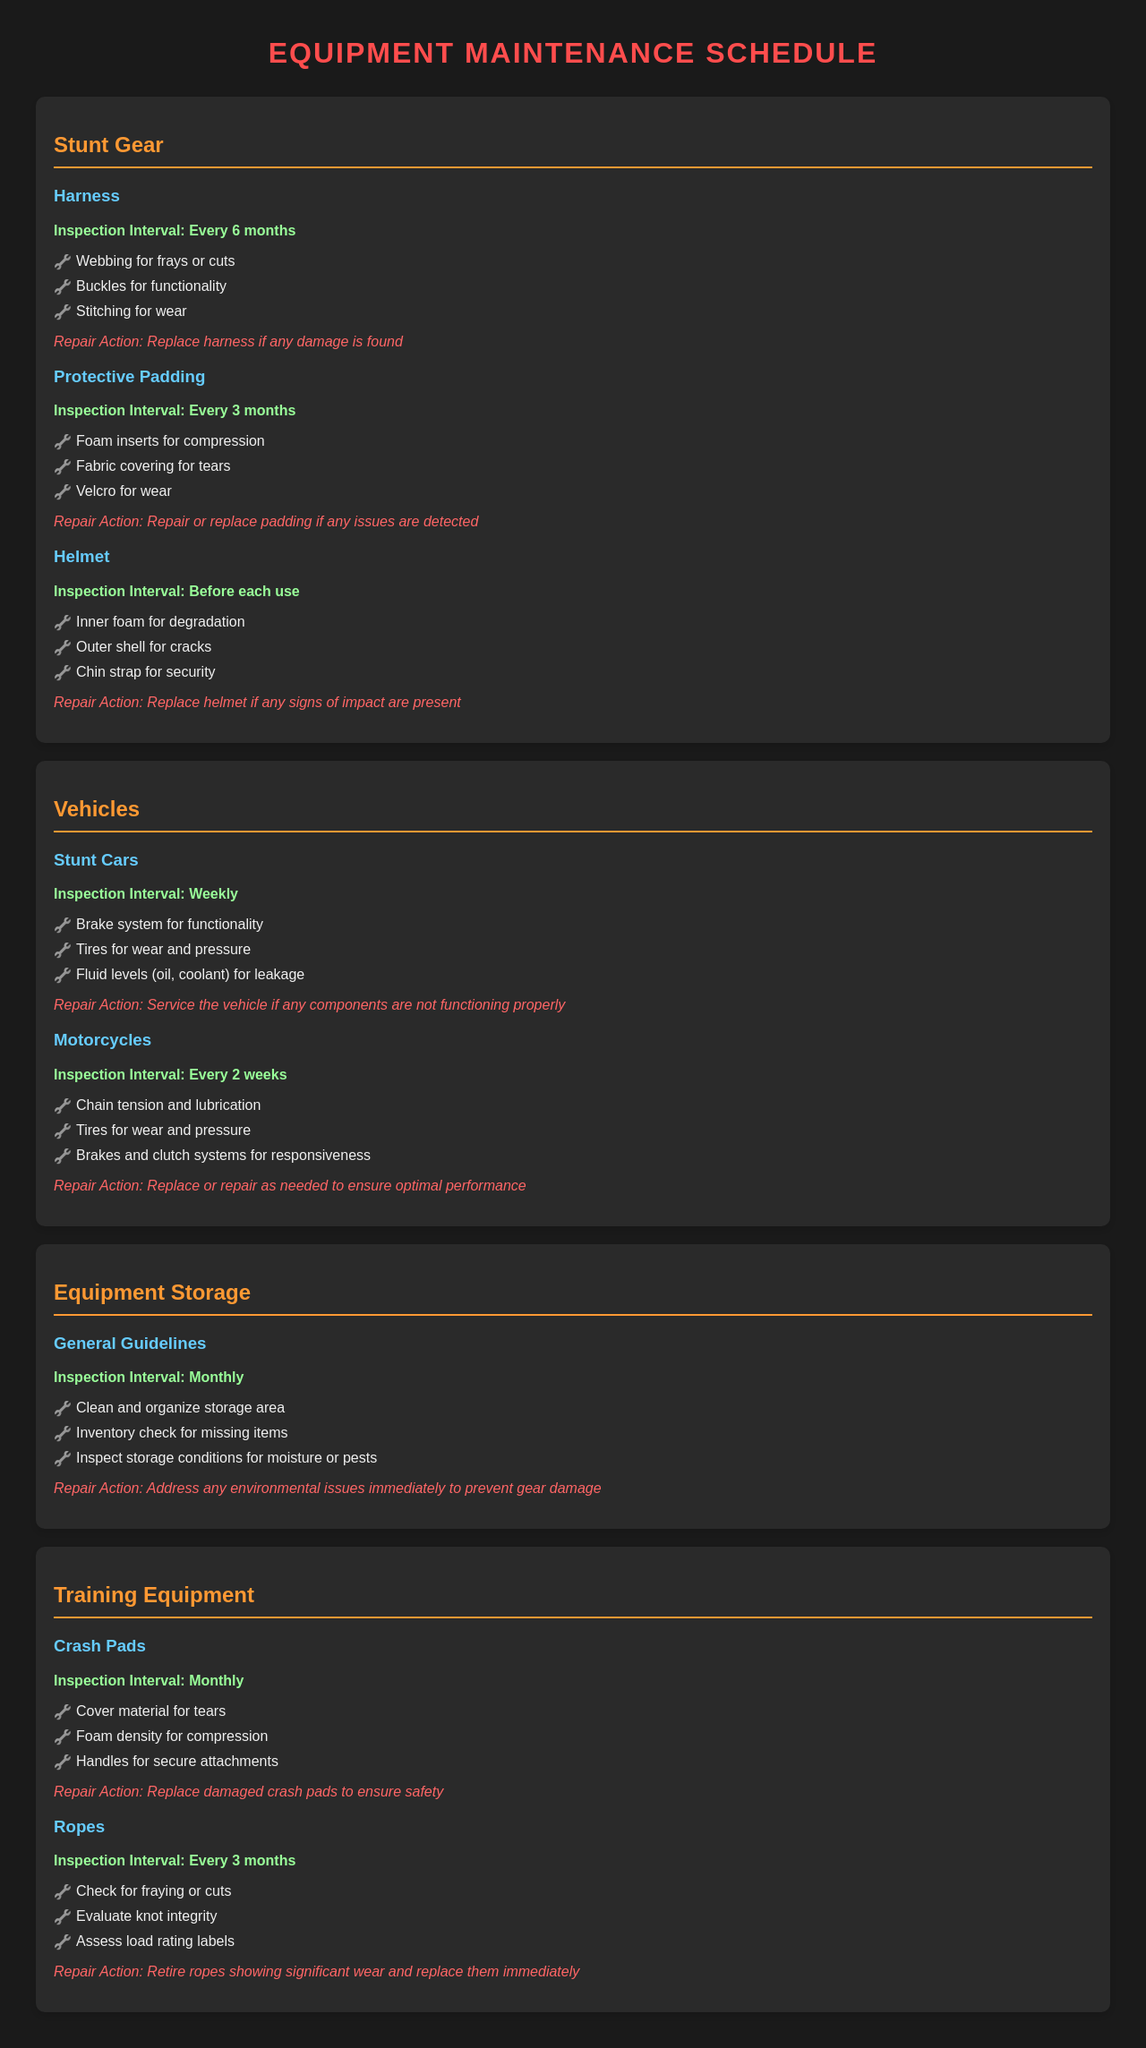What is the inspection interval for harnesses? The inspection interval for harnesses is specified in the document as every 6 months.
Answer: Every 6 months What should be inspected on the protective padding? The document lists specific items to inspect on the protective padding, including foam inserts, fabric covering, and Velcro.
Answer: Foam inserts, fabric covering, Velcro How often are stunt cars inspected? The scheduled inspection interval for stunt cars is provided in the document as weekly.
Answer: Weekly What is the repair action for a damaged helmet? The document states what action should be taken for a damaged helmet, specifically indicating that it should be replaced if signs of impact are present.
Answer: Replace helmet How frequently should crash pads be inspected? The inspection interval for crash pads is mentioned in the document as monthly.
Answer: Monthly What component must be checked on the motorcycle's brakes? The document indicates that responsiveness of the brakes must be checked during inspections of motorcycles.
Answer: Responsiveness What should be done if missing items are found during the equipment storage check? The document implies that missing items indicate the need for an inventory check, but does not specify further actions for when items are found missing.
Answer: Address missing items What guideline is stated for equipment storage inspections? The document lists general guidelines, including cleaning and organizing the storage area as one of the key tasks.
Answer: Clean and organize storage area What condition should ropes be evaluated for? The document specifies that ropes should be checked for fraying or cuts among other assessments.
Answer: Fraying or cuts 